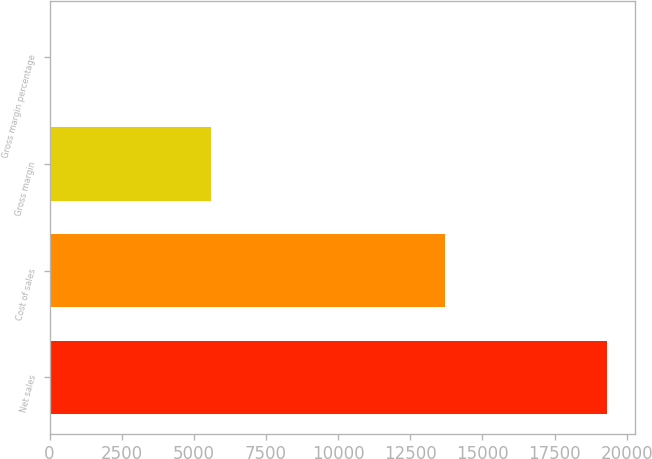Convert chart to OTSL. <chart><loc_0><loc_0><loc_500><loc_500><bar_chart><fcel>Net sales<fcel>Cost of sales<fcel>Gross margin<fcel>Gross margin percentage<nl><fcel>19315<fcel>13717<fcel>5598<fcel>29<nl></chart> 